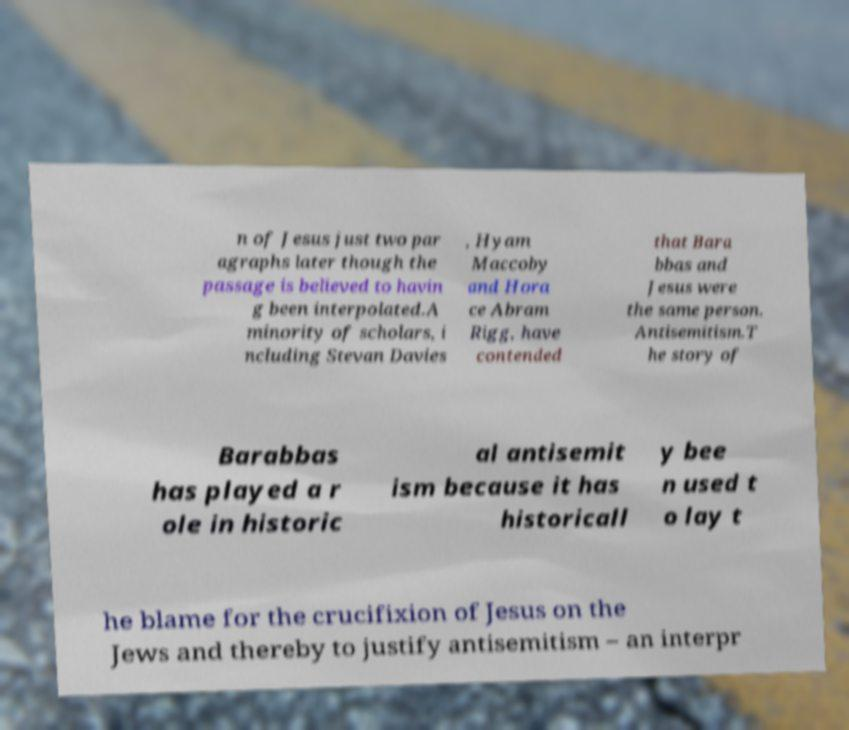Please read and relay the text visible in this image. What does it say? n of Jesus just two par agraphs later though the passage is believed to havin g been interpolated.A minority of scholars, i ncluding Stevan Davies , Hyam Maccoby and Hora ce Abram Rigg, have contended that Bara bbas and Jesus were the same person. Antisemitism.T he story of Barabbas has played a r ole in historic al antisemit ism because it has historicall y bee n used t o lay t he blame for the crucifixion of Jesus on the Jews and thereby to justify antisemitism – an interpr 